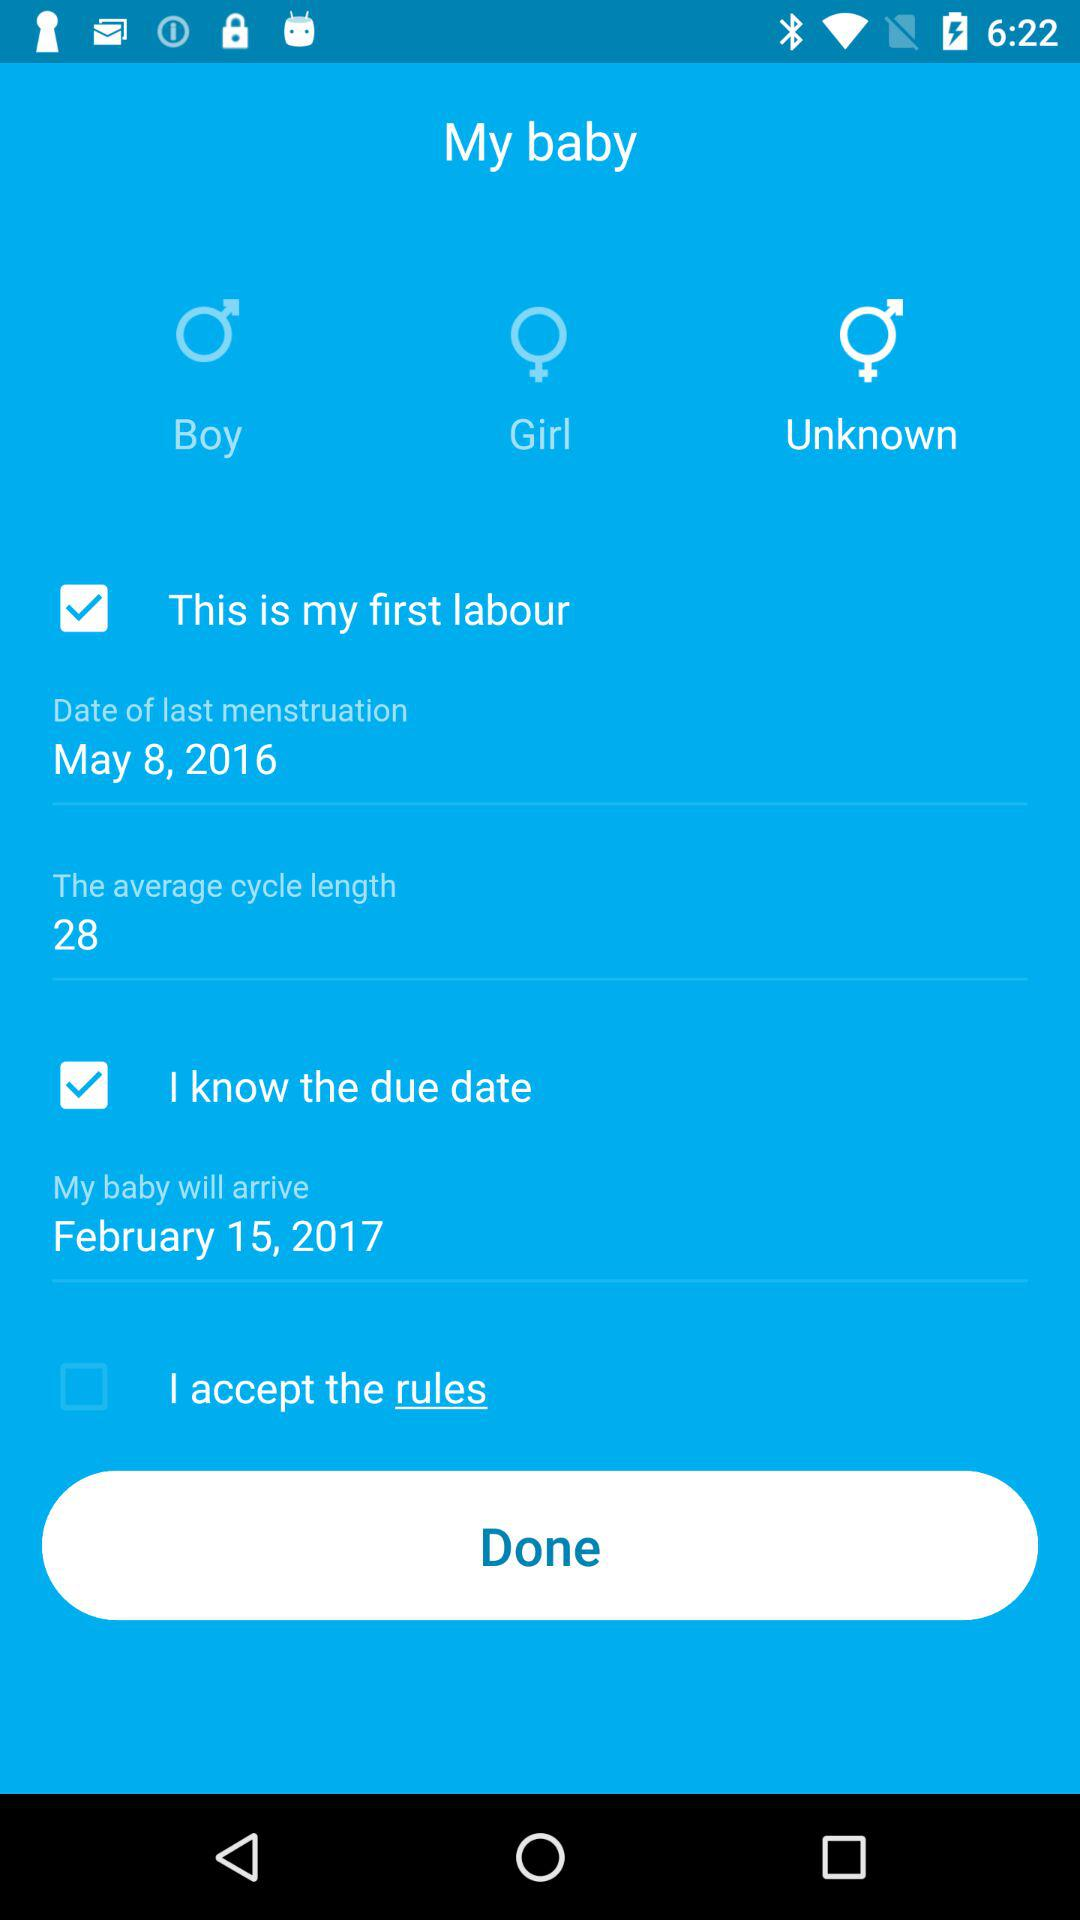What are the rules?
When the provided information is insufficient, respond with <no answer>. <no answer> 